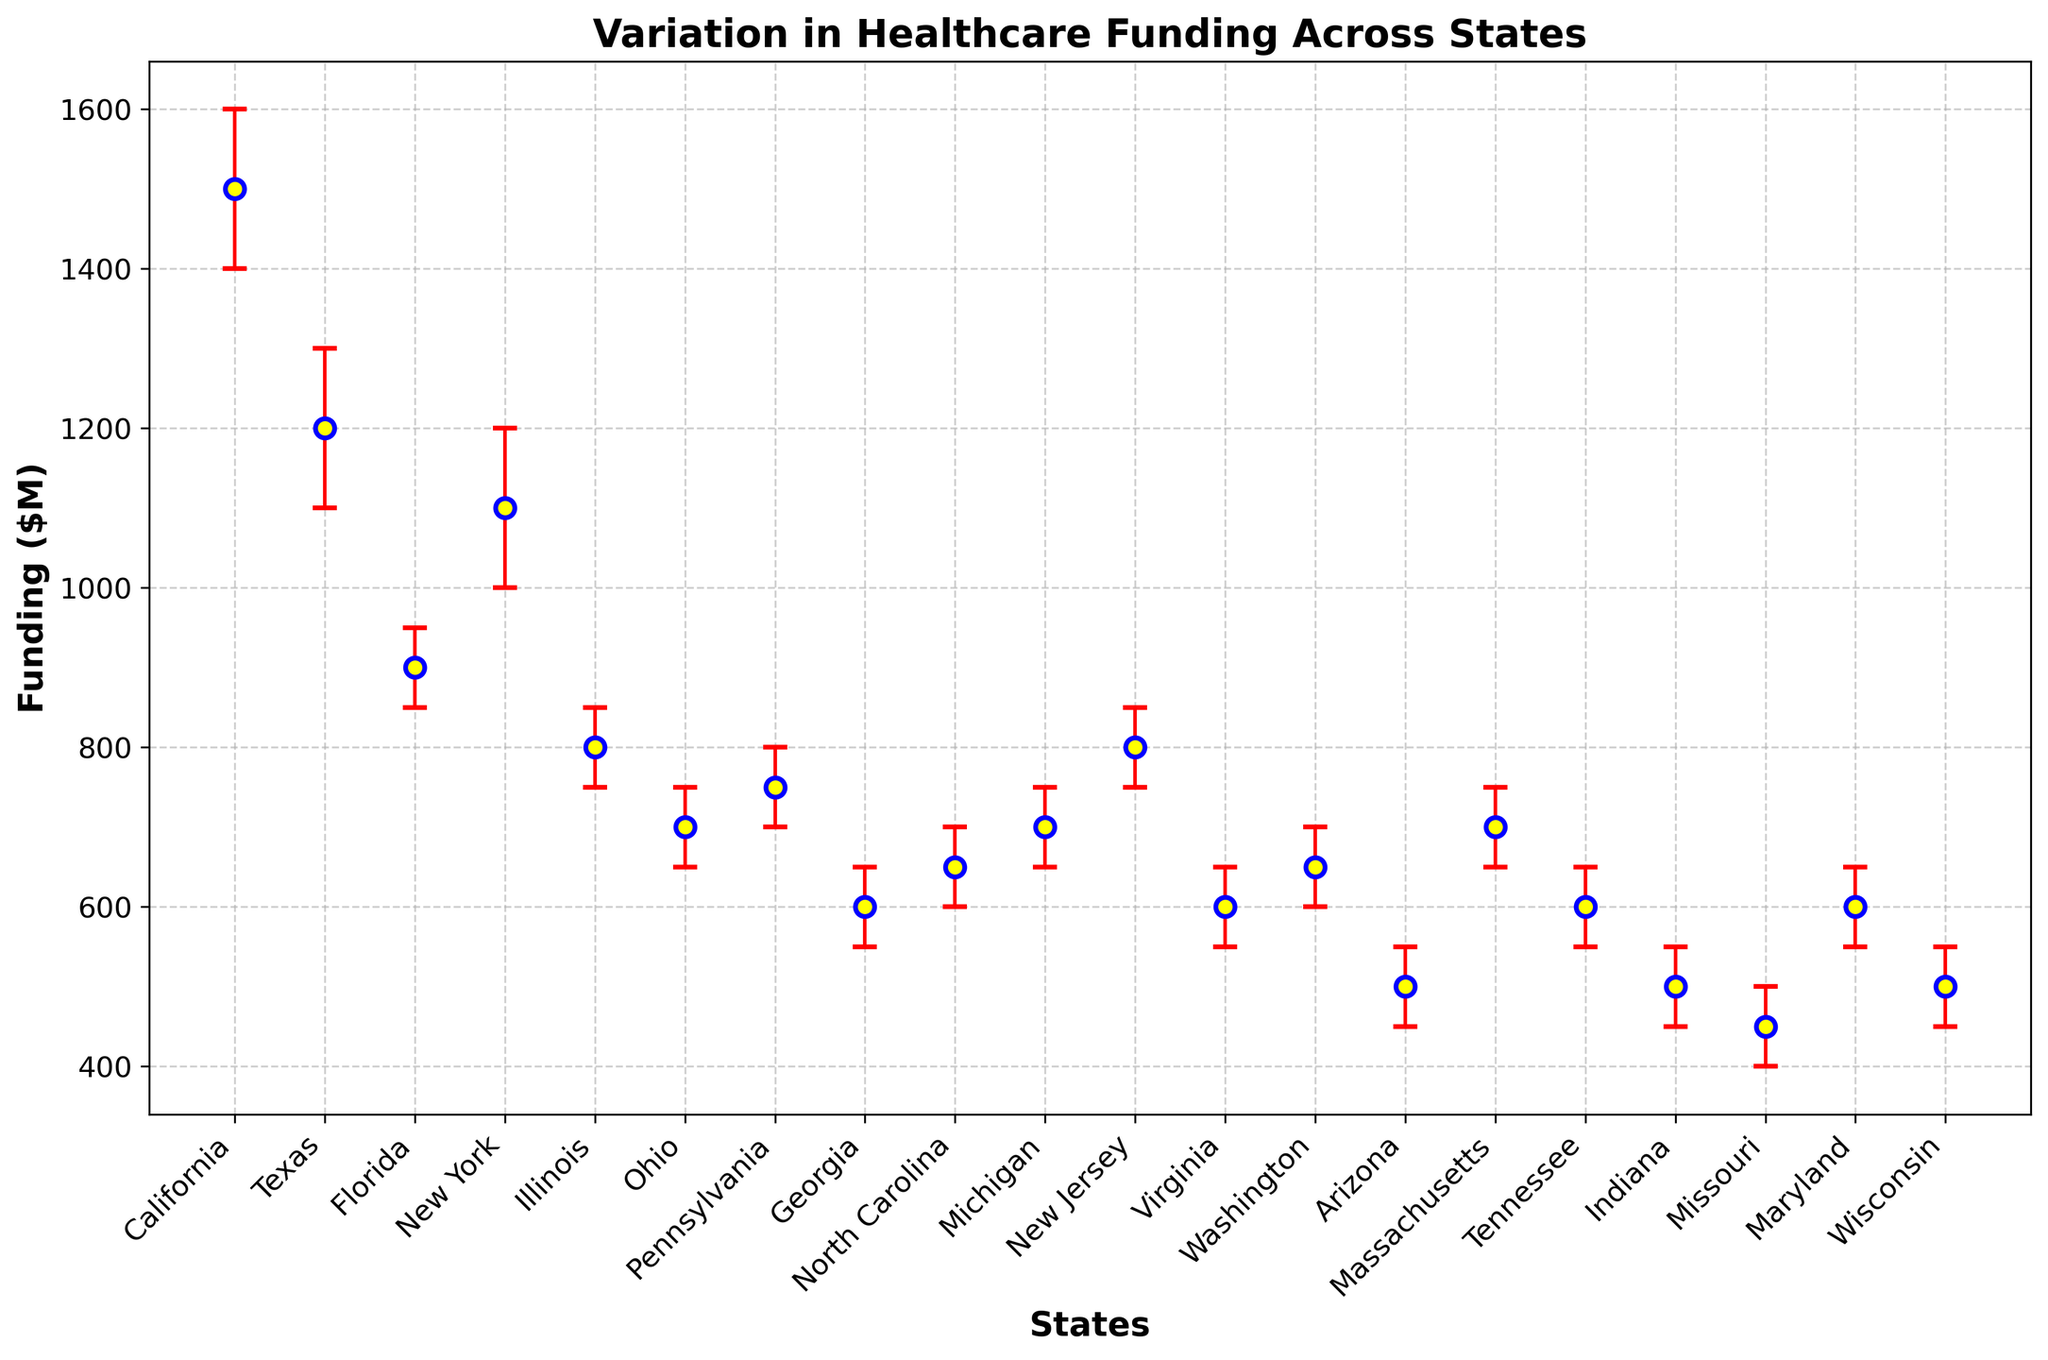Which state has the highest healthcare funding? By visually inspecting the plot, we can see which point (related to a state) is positioned the highest on the y-axis. California is at the top with the highest healthcare funding of $1500 million.
Answer: California Which state has the lowest healthcare funding? To determine the lowest funding, we identify the state whose point is positioned the lowest on the y-axis. Missouri is the lowest at $450 million.
Answer: Missouri What is the difference in healthcare funding between California and Texas? California has $1500 million, and Texas has $1200 million in healthcare funding. The difference is $1500 million - $1200 million = $300 million.
Answer: $300 million Which state has the largest uncertainty range in its healthcare funding? We need to look for the largest difference between the upper and lower uncertainty bars. Texas has an uncertainty range from $1100 million to $1300 million, which is 200 million, the highest range among all states.
Answer: Texas Is the funding for New Jersey closer to the funding of Florida or Illinois? New Jersey has $800 million in funding. Florida has $900 million and Illinois has $800 million. The absolute difference between New Jersey and Florida is $100 million ($900 - $800), and for Illinois, it is $0 ($800 - $800). So, New Jersey's funding is closer to Illinois.
Answer: Illinois What is the average funding for the states of Michigan, New Jersey, and Virginia? Michigan: $700M, New Jersey: $800M, Virginia: $600M. The average funding is calculated as ($700 + $800 + $600) / 3 = $2100 / 3 = $700 million.
Answer: $700 million Which states have similar uncertainty ranges with equal upper and lower bounds? We look for states where the difference between the upper and lower uncertainty is the same and equal to $50 million. States that fit this are Illinois, Georgia, and Washington.
Answer: Illinois, Georgia, Washington What is the total healthcare funding for the top three states? The top three states in terms of funding are California ($1500M), Texas ($1200M), and New York ($1100M). The total funding is $1500M + $1200M + $1100M = $3800 million.
Answer: $3800 million Which state has the smallest relative uncertainty in healthcare funding? The relative uncertainty is determined by the range of uncertainty divided by the funding. The state with the smallest ratio of uncertainty to funding must be identified by calculating the value for each state. For instance, Illinois has an uncertainty range of $100 million and a funding of $800 million, so the relative uncertainty is $100/$800 = 0.125. By calculating for all, Pennsylvania (100/750 = 0.133) and Texas have higher ratios. Illinois has the smallest relative uncertainty.
Answer: Illinois By how much does funding for Arizona fall short compared to the average state funding? First, calculate the average funding. The total funding across 20 states is $1500M + $1200M + $900M + $1100M + $800M + $700M + $750M + $600M + $650M + $700M + $800M + $600M + $650M + $500M + $700M + $600M + $500M + $450M + $600M + $500M = $16200M. Average funding = $16200M / 20 = $810M. The shortfall for Arizona is $810M - $500M = $310M.
Answer: $310 million 